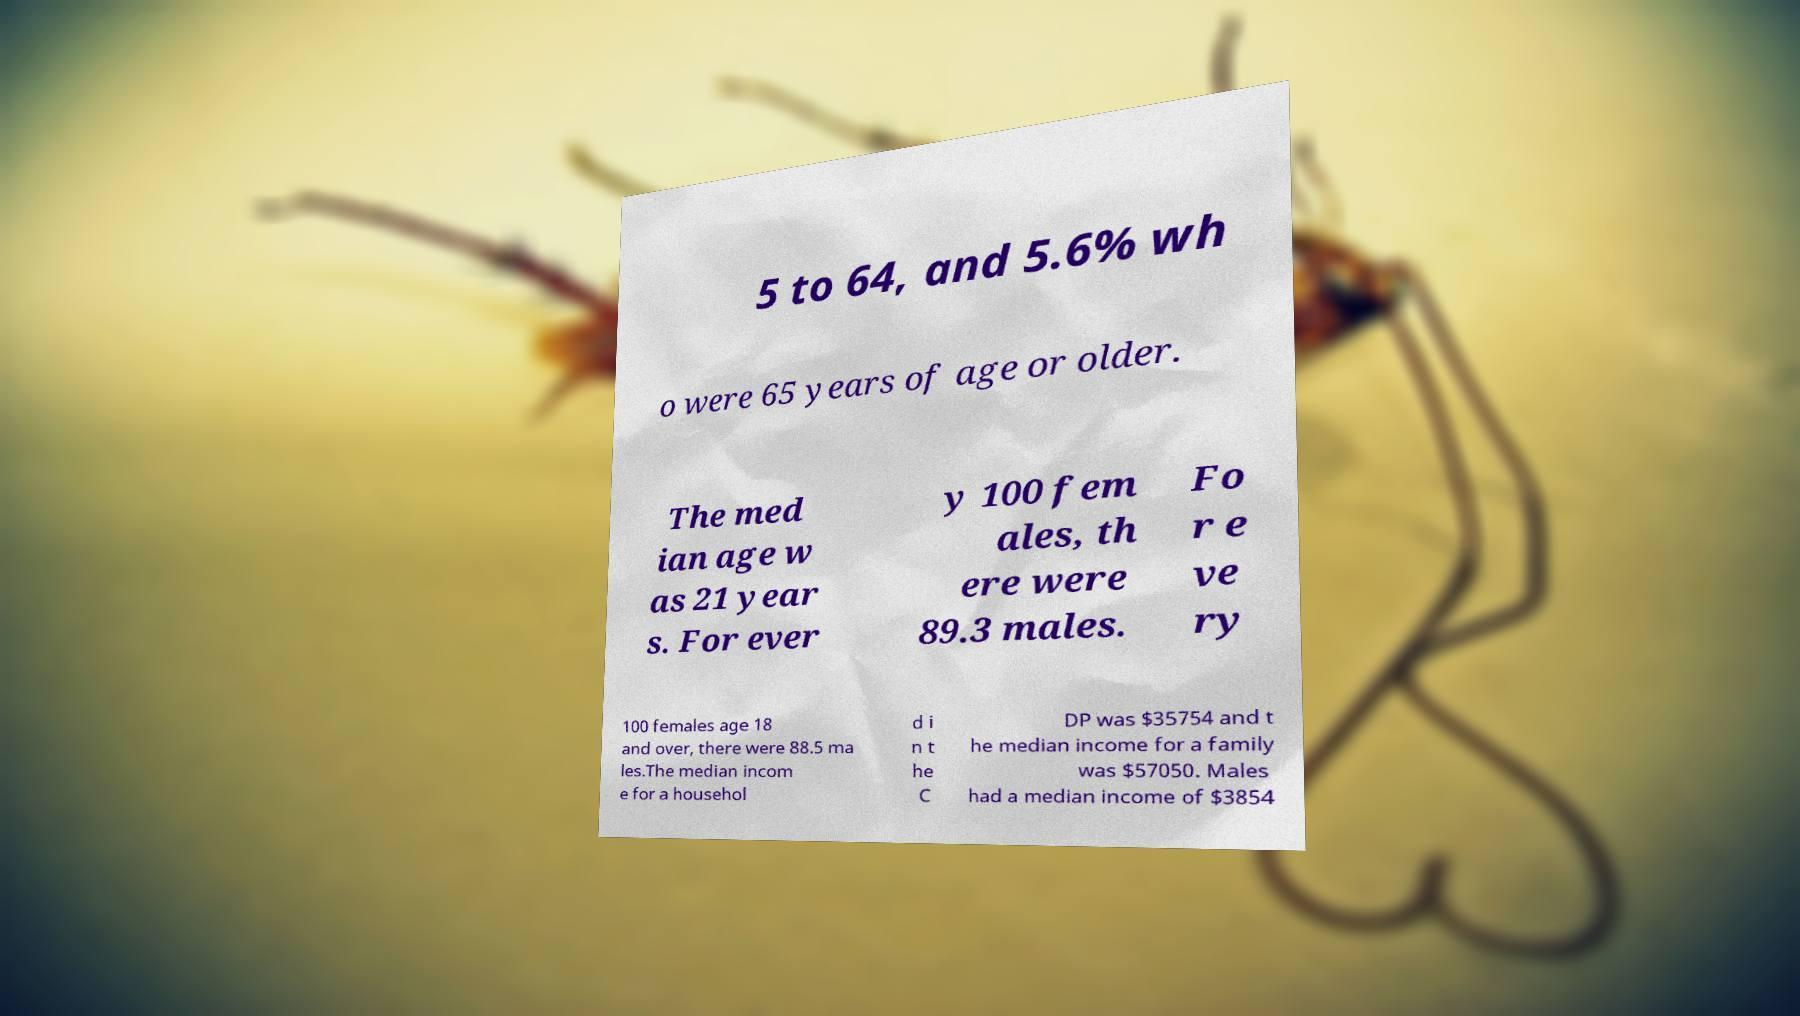Please read and relay the text visible in this image. What does it say? 5 to 64, and 5.6% wh o were 65 years of age or older. The med ian age w as 21 year s. For ever y 100 fem ales, th ere were 89.3 males. Fo r e ve ry 100 females age 18 and over, there were 88.5 ma les.The median incom e for a househol d i n t he C DP was $35754 and t he median income for a family was $57050. Males had a median income of $3854 